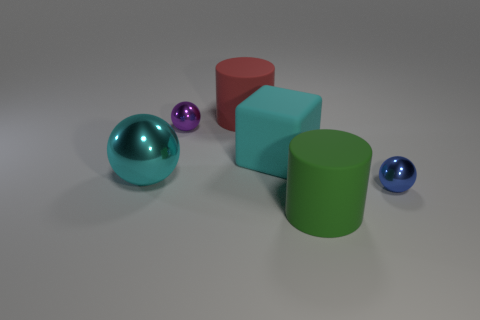Add 2 green things. How many objects exist? 8 Subtract all tiny blue spheres. How many spheres are left? 2 Subtract all blue balls. How many balls are left? 2 Subtract all cylinders. How many objects are left? 4 Subtract all red blocks. Subtract all brown balls. How many blocks are left? 1 Subtract all red rubber cylinders. Subtract all tiny metallic balls. How many objects are left? 3 Add 6 large cyan rubber things. How many large cyan rubber things are left? 7 Add 5 purple balls. How many purple balls exist? 6 Subtract 0 gray blocks. How many objects are left? 6 